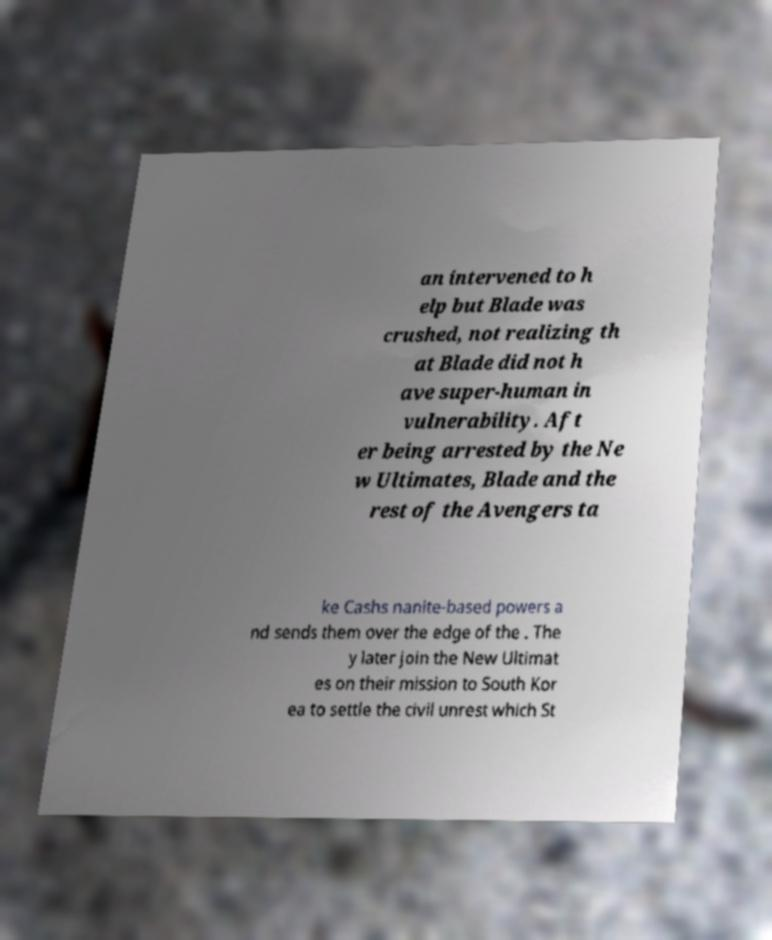Can you read and provide the text displayed in the image?This photo seems to have some interesting text. Can you extract and type it out for me? an intervened to h elp but Blade was crushed, not realizing th at Blade did not h ave super-human in vulnerability. Aft er being arrested by the Ne w Ultimates, Blade and the rest of the Avengers ta ke Cashs nanite-based powers a nd sends them over the edge of the . The y later join the New Ultimat es on their mission to South Kor ea to settle the civil unrest which St 